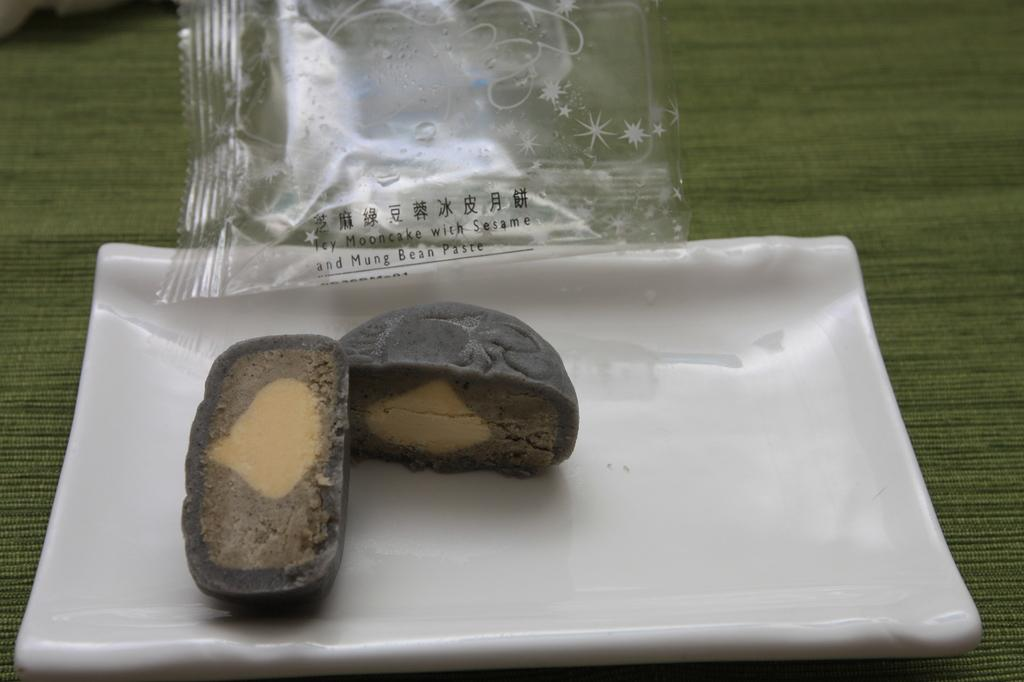What type of items are present in the image? There are eatable items in the image. How are the eatable items arranged or organized in the image? The eatable items are kept in a plate. What type of pies can be seen in the image? There is no specific mention of pies in the image; it only states that there are eatable items. Can you see any fangs on the eatable items in the image? There are no fangs present on the eatable items in the image, as they are not living creatures. 